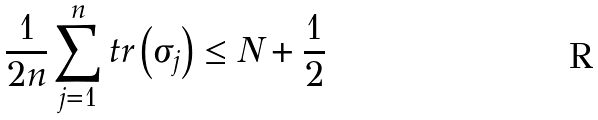Convert formula to latex. <formula><loc_0><loc_0><loc_500><loc_500>\frac { 1 } { 2 n } \sum _ { j = 1 } ^ { n } t r \left ( \sigma _ { j } \right ) \leq N + \frac { 1 } { 2 }</formula> 